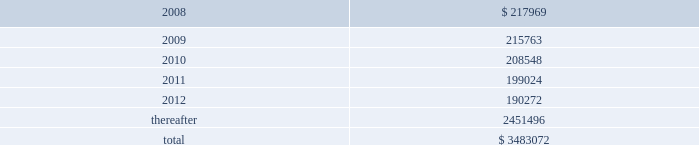American tower corporation and subsidiaries notes to consolidated financial statements 2014 ( continued ) as of december 31 , 2006 , the company held a total of ten interest rate swap agreements to manage exposure to variable rate interest obligations under its amt opco and spectrasite credit facilities and four forward starting interest rate swap agreements to manage exposure to variability in cash flows relating to forecasted interest payments in connection with the securitization which the company designated as cash flow hedges .
The eight american tower swaps had an aggregate notional amount of $ 450.0 million and fixed rates ranging between 4.63% ( 4.63 % ) and 4.88% ( 4.88 % ) and the two spectrasite swaps have an aggregate notional amount of $ 100.0 million and a fixed rate of 4.95% ( 4.95 % ) .
The four forward starting interest rate swap agreements had an aggregate notional amount of $ 900.0 million , fixed rates ranging between 4.73% ( 4.73 % ) and 5.10% ( 5.10 % ) .
As of december 31 , 2006 , the company also held three interest rate swap instruments and one interest rate cap instrument that were acquired in the spectrasite , inc .
Merger in august 2005 and were not designated as cash flow hedges .
The three interest rate swaps , which had a fair value of $ 6.7 million at the date of acquisition , have an aggregate notional amount of $ 300.0 million , a fixed rate of 3.88% ( 3.88 % ) .
The interest rate cap had a notional amount of $ 175.0 million , a fixed rate of 7.0% ( 7.0 % ) , and expired in february 2006 .
As of december 31 , 2006 , other comprehensive income includes unrealized gains on short term available-for-sale securities of $ 10.4 million and unrealized gains related to the interest rate swap agreements in the table above of $ 5.7 million , net of tax .
During the year ended december 31 , 2006 , the company recorded a net unrealized gain of approximately $ 6.5 million ( net of a tax provision of approximately $ 3.5 million ) in other comprehensive loss for the change in fair value of interest rate swaps designated as cash flow hedges and reclassified $ 0.7 million ( net of an income tax benefit of $ 0.2 million ) into results of operations during the year ended december 31 , 2006 .
Commitments and contingencies lease obligations 2014the company leases certain land , office and tower space under operating leases that expire over various terms .
Many of the leases contain renewal options with specified increases in lease payments upon exercise of the renewal option .
Escalation clauses present in operating leases , excluding those tied to cpi or other inflation-based indices , are recognized on a straight-line basis over the non-cancelable term of the lease .
( see note 1. ) future minimum rental payments under non-cancelable operating leases include payments for certain renewal periods at the company 2019s option because failure to renew could result in a loss of the applicable tower site and related revenues from tenant leases , thereby making it reasonably assured that the company will renew the lease .
Such payments in effect at december 31 , 2007 are as follows ( in thousands ) : year ending december 31 .
Aggregate rent expense ( including the effect of straight-line rent expense ) under operating leases for the years ended december 31 , 2007 , 2006 and 2005 approximated $ 246.4 million , $ 237.0 million and $ 168.7 million , respectively. .
What is the percentage change in aggregate rent expense from 2006 to 2007? 
Computations: ((246.4 - 237.0) / 237.0)
Answer: 0.03966. 